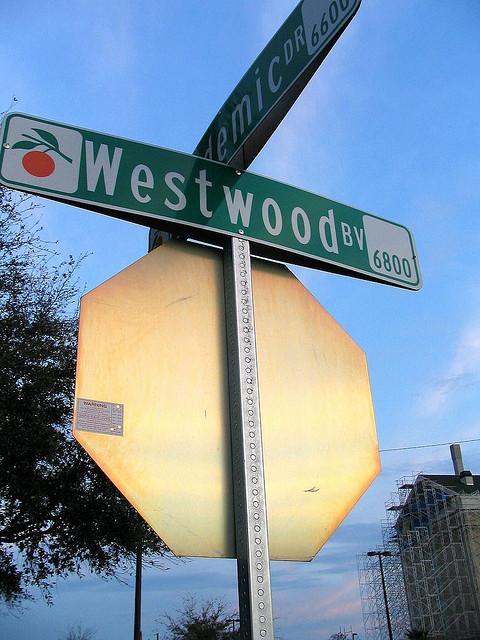Is there a building getting built?
Write a very short answer. Yes. Was the picture taken at night?
Give a very brief answer. No. What street is this?
Concise answer only. Westwood. 